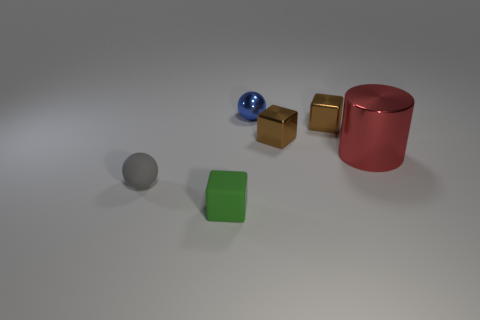Add 4 purple balls. How many objects exist? 10 Subtract all spheres. How many objects are left? 4 Add 3 small brown metallic cubes. How many small brown metallic cubes are left? 5 Add 2 large gray matte cylinders. How many large gray matte cylinders exist? 2 Subtract 0 cyan spheres. How many objects are left? 6 Subtract all small purple metallic cylinders. Subtract all small brown metallic objects. How many objects are left? 4 